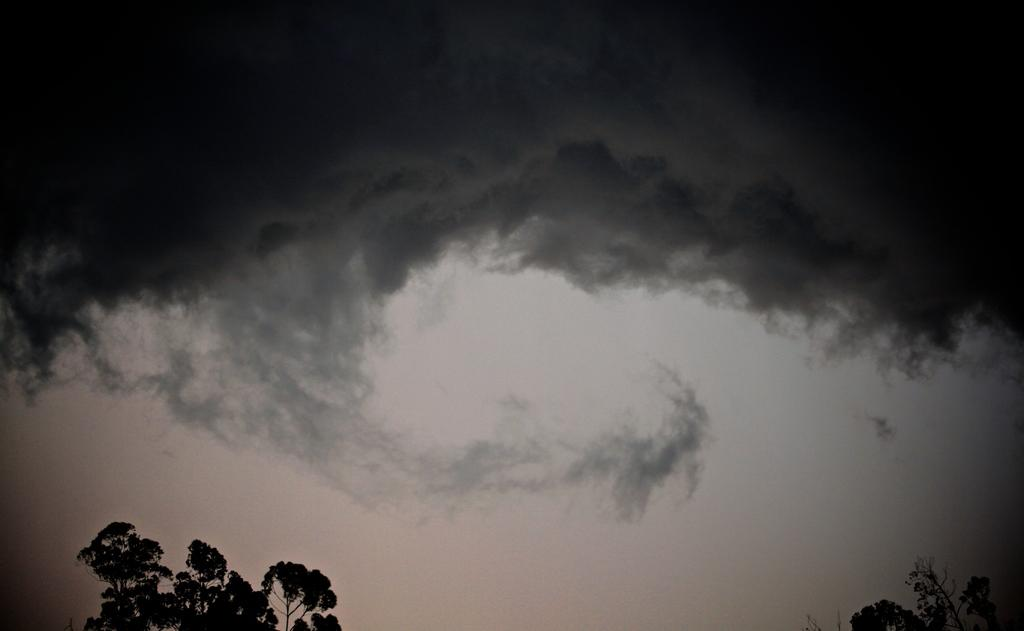What type of vegetation can be seen in the image? There are trees in the image. What is visible in the background of the image? The sky is visible in the background of the image. What can be observed in the sky? Clouds are present in the sky. What type of punishment is being handed out by the lawyer in the image? There is no lawyer or punishment present in the image; it features trees and clouds in the sky. What is the mind of the tree thinking in the image? Trees do not have minds, so it is not possible to determine what a tree might be thinking in the image. 